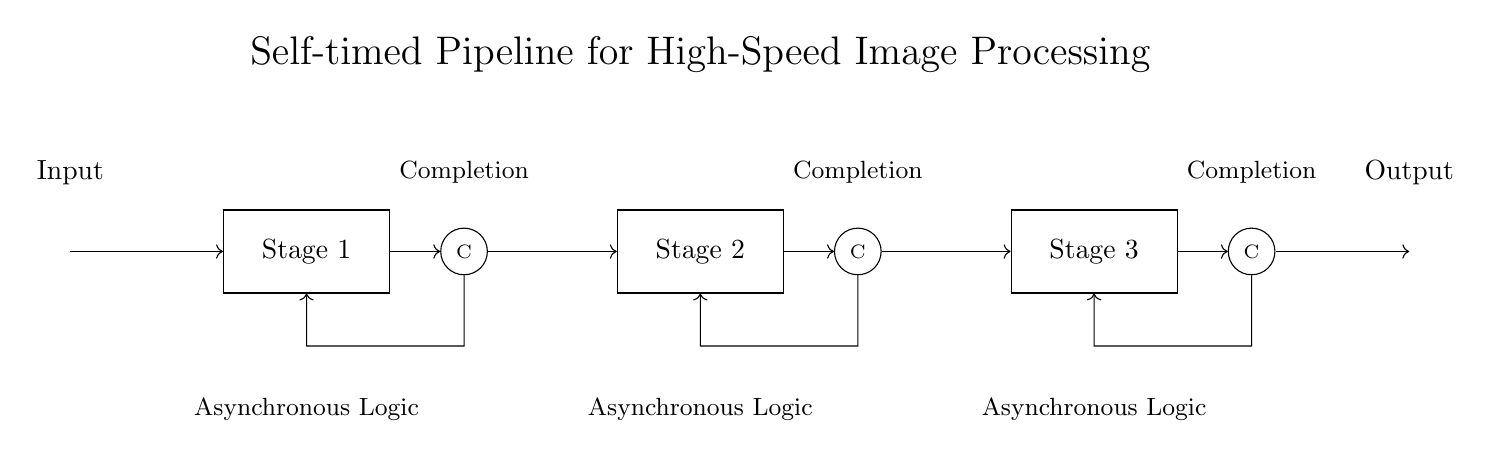What are the stages in the pipeline? The stages in the pipeline are Stage 1, Stage 2, and Stage 3, identified clearly in the circuit diagram as rectangular blocks labeled accordingly.
Answer: Stage 1, Stage 2, Stage 3 What type of logic is used in this circuit? The circuit uses asynchronous logic as indicated below each of the stage blocks in the diagram.
Answer: Asynchronous Logic How many completion nodes are present? There are three completion nodes, each located above the respective stage blocks, denoting the completion of each stage's processing.
Answer: Three What direction do the output connections have? The output connections flow in a rightward direction from the last stage block towards the output node, as shown by the arrows in the diagram.
Answer: Rightward How does feedback occur in this circuit? Feedback occurs through the connections that loop back from each completion node to the respective stage, demonstrating how the circuit monitors and controls its processing dynamically.
Answer: Through feedback paths What is the primary function of the completion nodes? The completion nodes serve to signal when processing at each stage is finished, indicating that the output can proceed to the next stage, as depicted by their labeled position in the circuit diagram.
Answer: Signal completion What does the layout of the circuit indicate about its speed? The layout, featuring a self-timed pipeline design with multiple stages and asynchronous logic, indicates the potential for high-speed processing because each stage can operate independently and concurrently.
Answer: High-speed processing 